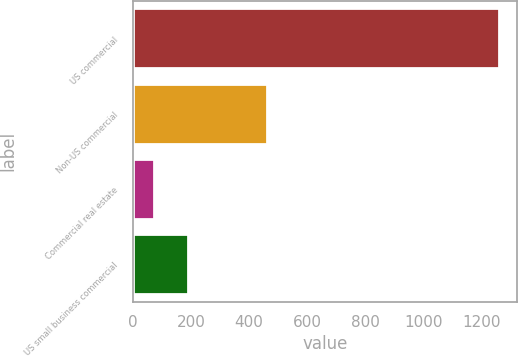Convert chart to OTSL. <chart><loc_0><loc_0><loc_500><loc_500><bar_chart><fcel>US commercial<fcel>Non-US commercial<fcel>Commercial real estate<fcel>US small business commercial<nl><fcel>1260<fcel>463<fcel>73<fcel>191.7<nl></chart> 